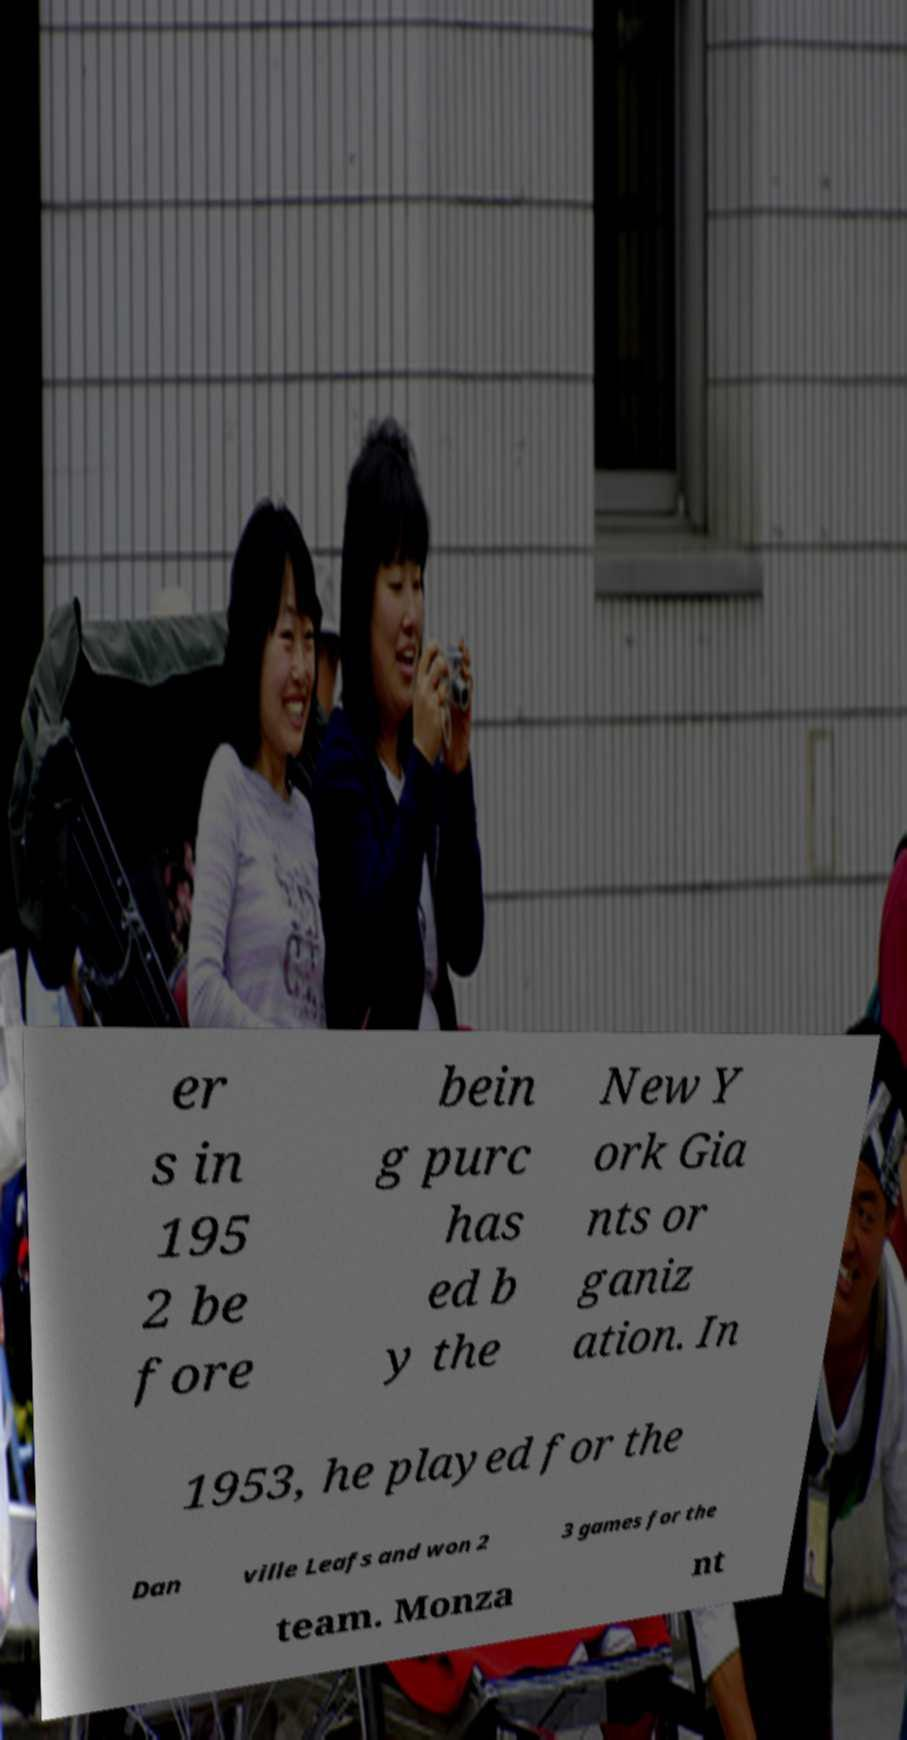Could you extract and type out the text from this image? er s in 195 2 be fore bein g purc has ed b y the New Y ork Gia nts or ganiz ation. In 1953, he played for the Dan ville Leafs and won 2 3 games for the team. Monza nt 